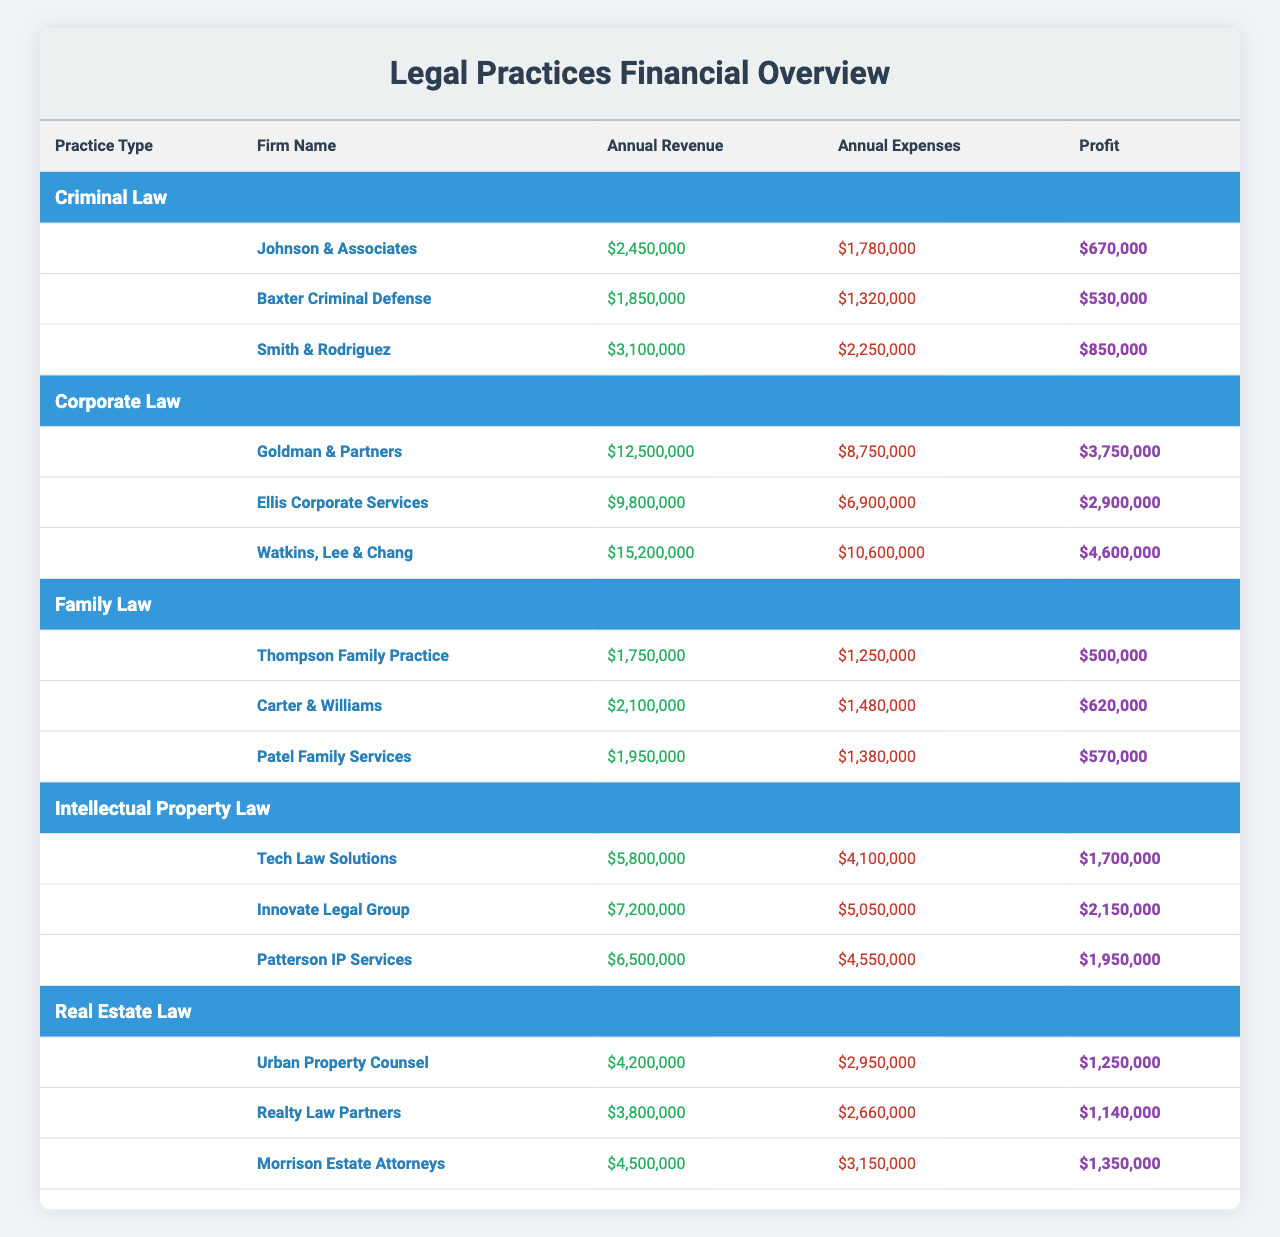What is the total annual revenue for all firms in Corporate Law? The practice type Corporate Law has three firms: Goldman & Partners ($12,500,000), Ellis Corporate Services ($9,800,000), and Watkins, Lee & Chang ($15,200,000). Adding these values gives us $12,500,000 + $9,800,000 + $15,200,000 = $37,500,000.
Answer: $37,500,000 Which firm has the highest profit in Family Law? The firms in Family Law are Thompson Family Practice ($500,000), Carter & Williams ($620,000), and Patel Family Services ($570,000). Comparing the profits shows that Carter & Williams has the highest at $620,000.
Answer: Carter & Williams Is the annual revenue of Tech Law Solutions greater than the combined annual revenue of the other Intellectual Property Law firms? Tech Law Solutions has an annual revenue of $5,800,000. The other firms are Innovate Legal Group ($7,200,000) and Patterson IP Services ($6,500,000). Combined, they add up to $7,200,000 + $6,500,000 = $13,700,000. Since $5,800,000 is less than $13,700,000, the statement is false.
Answer: No What is the average profit for firms in Real Estate Law? The profits for the firms are: Urban Property Counsel ($1,250,000), Realty Law Partners ($1,140,000), and Morrison Estate Attorneys ($1,350,000). First, sum the profits: $1,250,000 + $1,140,000 + $1,350,000 = $3,740,000. Then, divide by the number of firms (3): $3,740,000 / 3 = $1,246,666.67.
Answer: $1,246,666.67 Is the total annual expenses for Criminal Law firms less than $5 million? The annual expenses for Criminal Law firms are: Johnson & Associates ($1,780,000), Baxter Criminal Defense ($1,320,000), and Smith & Rodriguez ($2,250,000). Summing them gives $1,780,000 + $1,320,000 + $2,250,000 = $5,350,000, which is greater than $5 million, so the statement is false.
Answer: No 